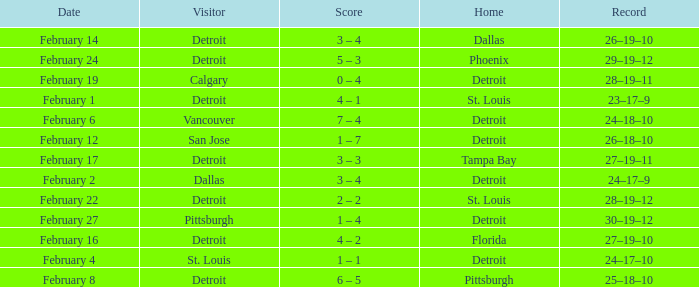What was their performance when they were at pittsburgh? 25–18–10. 